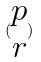<formula> <loc_0><loc_0><loc_500><loc_500>( \begin{matrix} p \\ r \end{matrix} )</formula> 